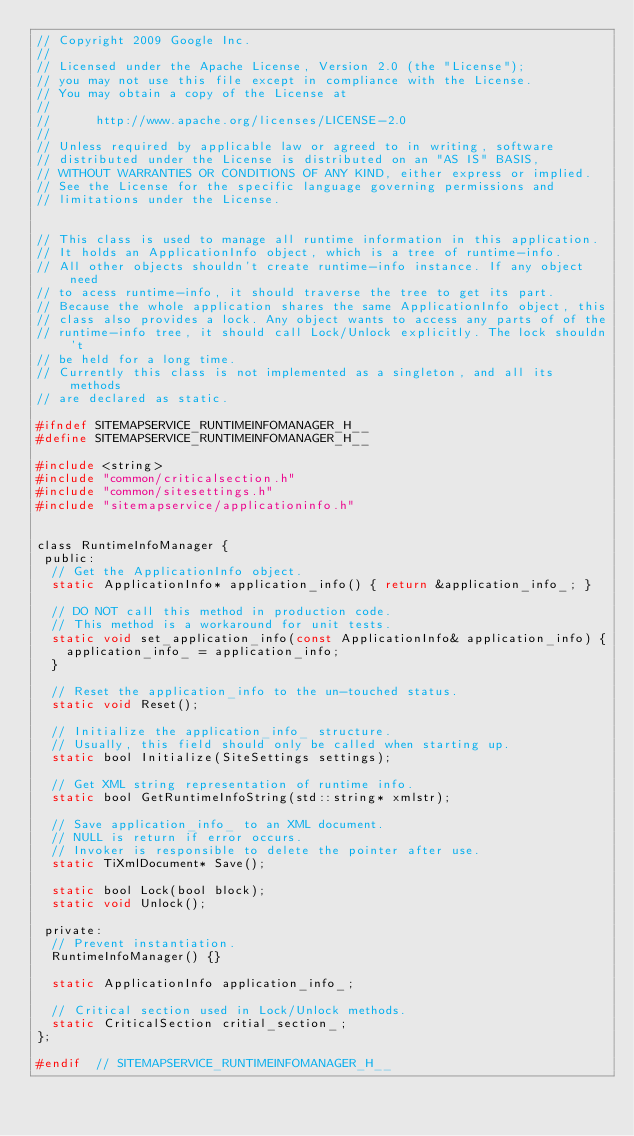Convert code to text. <code><loc_0><loc_0><loc_500><loc_500><_C_>// Copyright 2009 Google Inc.
//
// Licensed under the Apache License, Version 2.0 (the "License");
// you may not use this file except in compliance with the License.
// You may obtain a copy of the License at
//
//      http://www.apache.org/licenses/LICENSE-2.0
//
// Unless required by applicable law or agreed to in writing, software
// distributed under the License is distributed on an "AS IS" BASIS,
// WITHOUT WARRANTIES OR CONDITIONS OF ANY KIND, either express or implied.
// See the License for the specific language governing permissions and
// limitations under the License.


// This class is used to manage all runtime information in this application.
// It holds an ApplicationInfo object, which is a tree of runtime-info.
// All other objects shouldn't create runtime-info instance. If any object need
// to acess runtime-info, it should traverse the tree to get its part.
// Because the whole application shares the same ApplicationInfo object, this
// class also provides a lock. Any object wants to access any parts of of the
// runtime-info tree, it should call Lock/Unlock explicitly. The lock shouldn't
// be held for a long time.
// Currently this class is not implemented as a singleton, and all its methods
// are declared as static.

#ifndef SITEMAPSERVICE_RUNTIMEINFOMANAGER_H__
#define SITEMAPSERVICE_RUNTIMEINFOMANAGER_H__

#include <string>
#include "common/criticalsection.h"
#include "common/sitesettings.h"
#include "sitemapservice/applicationinfo.h"


class RuntimeInfoManager {
 public:
  // Get the ApplicationInfo object.
  static ApplicationInfo* application_info() { return &application_info_; }

  // DO NOT call this method in production code.
  // This method is a workaround for unit tests.
  static void set_application_info(const ApplicationInfo& application_info) {
    application_info_ = application_info;
  }

  // Reset the application_info to the un-touched status.
  static void Reset();

  // Initialize the application_info_ structure.
  // Usually, this field should only be called when starting up.
  static bool Initialize(SiteSettings settings);

  // Get XML string representation of runtime info.
  static bool GetRuntimeInfoString(std::string* xmlstr);

  // Save application_info_ to an XML document.
  // NULL is return if error occurs.
  // Invoker is responsible to delete the pointer after use.
  static TiXmlDocument* Save();

  static bool Lock(bool block);
  static void Unlock();

 private:
  // Prevent instantiation.
  RuntimeInfoManager() {}

  static ApplicationInfo application_info_;

  // Critical section used in Lock/Unlock methods.
  static CriticalSection critial_section_;
};

#endif  // SITEMAPSERVICE_RUNTIMEINFOMANAGER_H__
</code> 